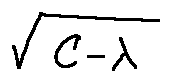<formula> <loc_0><loc_0><loc_500><loc_500>\sqrt { C - \lambda }</formula> 